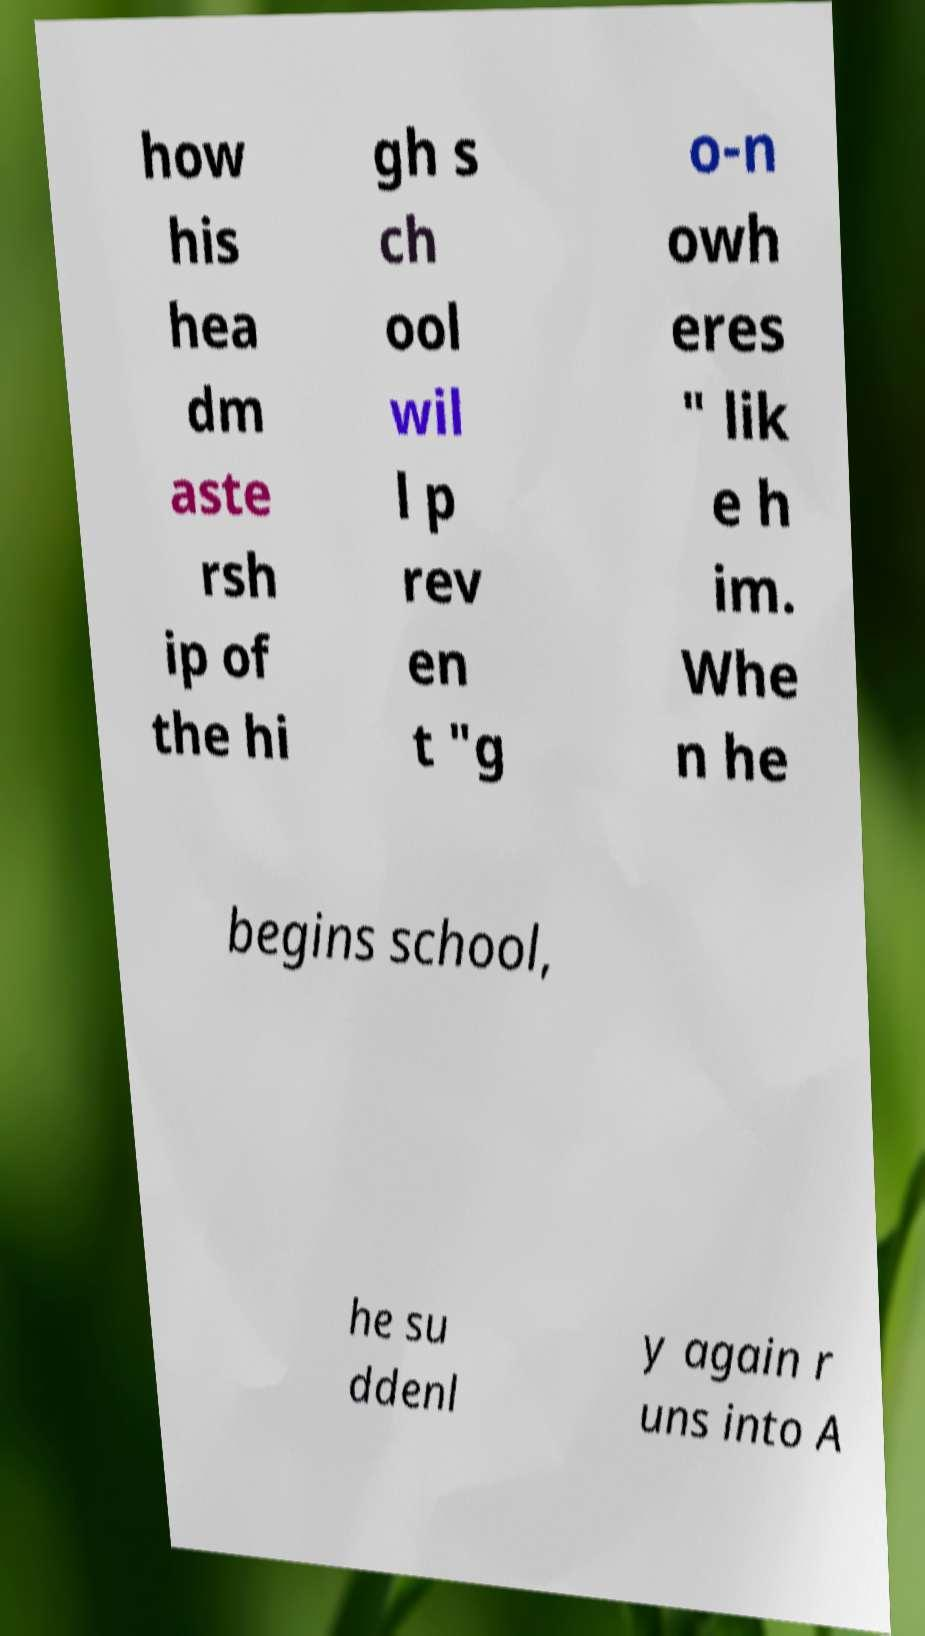Can you read and provide the text displayed in the image?This photo seems to have some interesting text. Can you extract and type it out for me? how his hea dm aste rsh ip of the hi gh s ch ool wil l p rev en t "g o-n owh eres " lik e h im. Whe n he begins school, he su ddenl y again r uns into A 